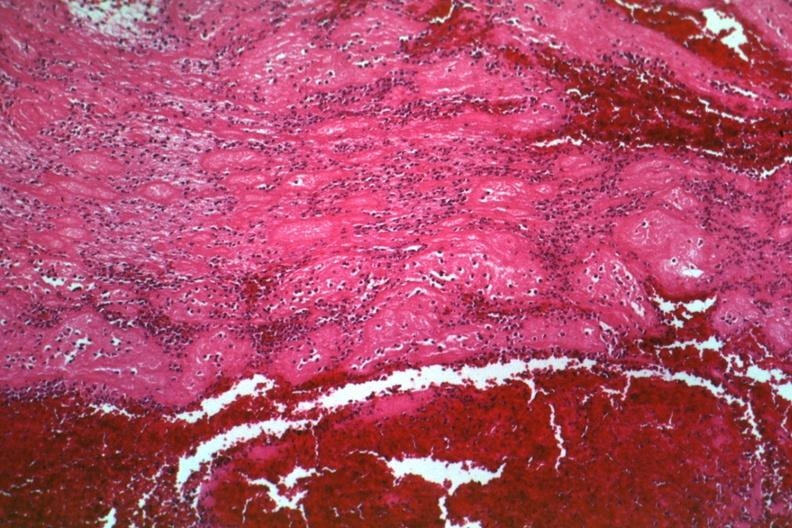what is present?
Answer the question using a single word or phrase. Hematologic 